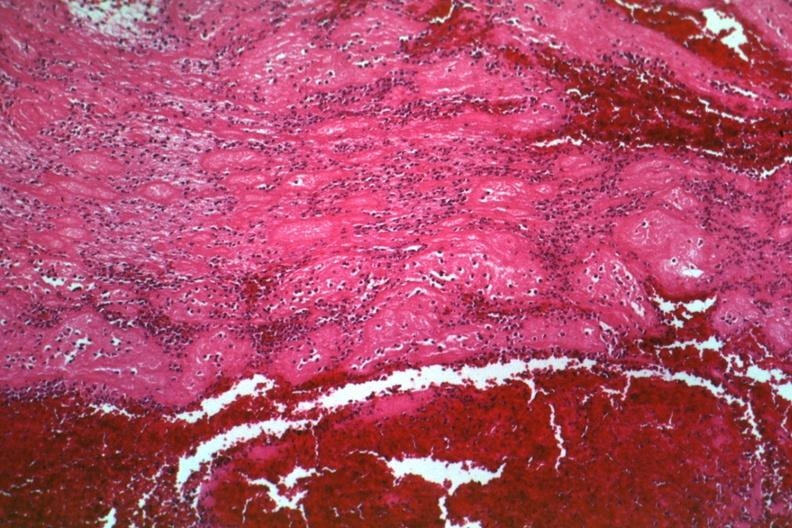what is present?
Answer the question using a single word or phrase. Hematologic 